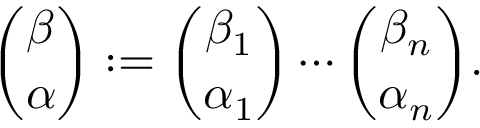<formula> <loc_0><loc_0><loc_500><loc_500>{ \binom { \beta } { \alpha } } \colon = { \binom { \beta _ { 1 } } { \alpha _ { 1 } } } \cdots { \binom { \beta _ { n } } { \alpha _ { n } } } .</formula> 